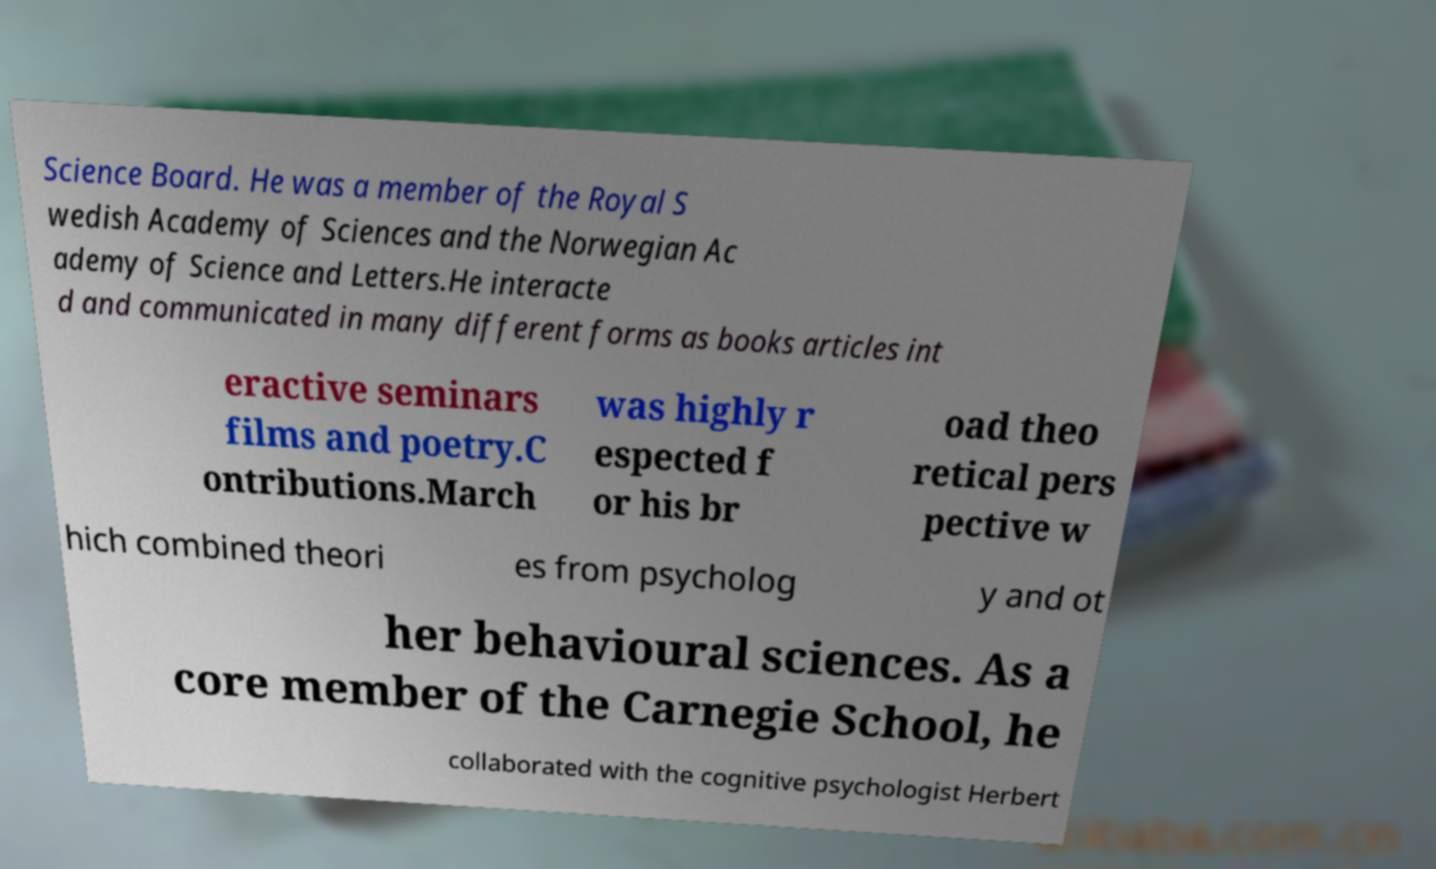I need the written content from this picture converted into text. Can you do that? Science Board. He was a member of the Royal S wedish Academy of Sciences and the Norwegian Ac ademy of Science and Letters.He interacte d and communicated in many different forms as books articles int eractive seminars films and poetry.C ontributions.March was highly r espected f or his br oad theo retical pers pective w hich combined theori es from psycholog y and ot her behavioural sciences. As a core member of the Carnegie School, he collaborated with the cognitive psychologist Herbert 